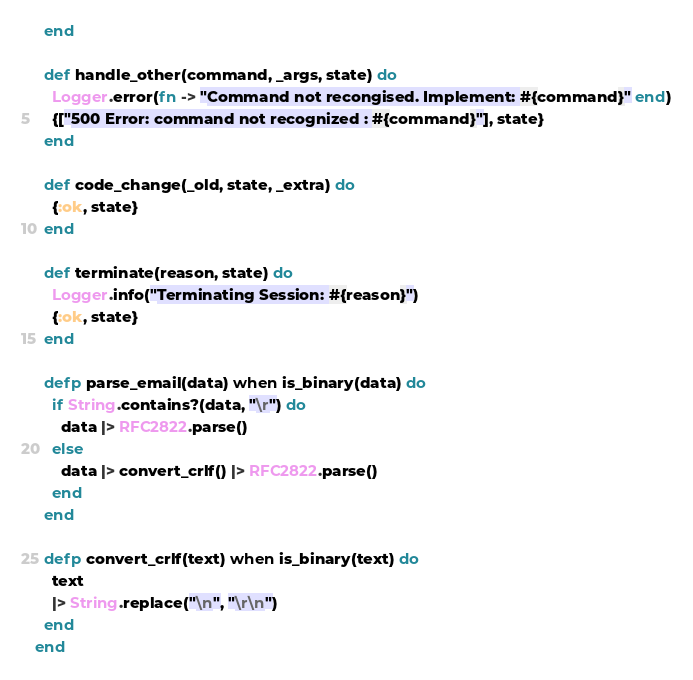<code> <loc_0><loc_0><loc_500><loc_500><_Elixir_>  end

  def handle_other(command, _args, state) do
    Logger.error(fn -> "Command not recongised. Implement: #{command}" end)
    {["500 Error: command not recognized : #{command}"], state}
  end

  def code_change(_old, state, _extra) do
    {:ok, state}
  end

  def terminate(reason, state) do
    Logger.info("Terminating Session: #{reason}")
    {:ok, state}
  end

  defp parse_email(data) when is_binary(data) do
    if String.contains?(data, "\r") do
      data |> RFC2822.parse()
    else
      data |> convert_crlf() |> RFC2822.parse()
    end
  end

  defp convert_crlf(text) when is_binary(text) do
    text
    |> String.replace("\n", "\r\n")
  end
end
</code> 